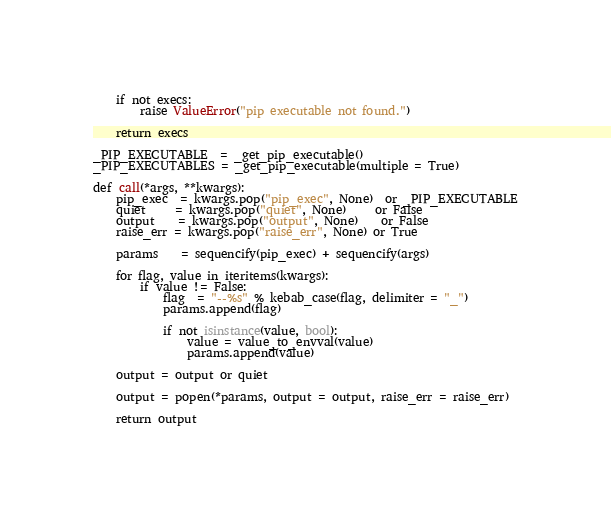<code> <loc_0><loc_0><loc_500><loc_500><_Python_>
    if not execs:
        raise ValueError("pip executable not found.")

    return execs

_PIP_EXECUTABLE  = _get_pip_executable()
_PIP_EXECUTABLES = _get_pip_executable(multiple = True)

def call(*args, **kwargs):
    pip_exec  = kwargs.pop("pip_exec", None)  or _PIP_EXECUTABLE
    quiet     = kwargs.pop("quiet", None)     or False
    output    = kwargs.pop("output", None)    or False
    raise_err = kwargs.pop("raise_err", None) or True

    params    = sequencify(pip_exec) + sequencify(args)
    
    for flag, value in iteritems(kwargs):
        if value != False:
            flag  = "--%s" % kebab_case(flag, delimiter = "_")
            params.append(flag)

            if not isinstance(value, bool):
                value = value_to_envval(value)
                params.append(value)

    output = output or quiet
	
    output = popen(*params, output = output, raise_err = raise_err)
    
    return output</code> 